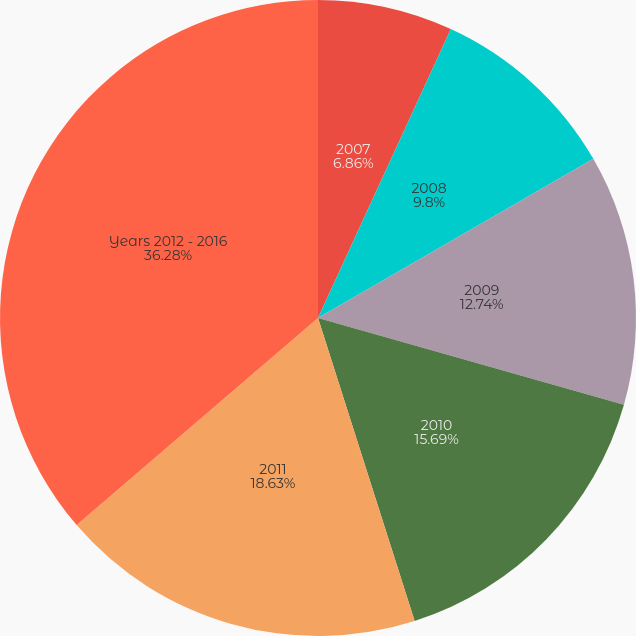Convert chart. <chart><loc_0><loc_0><loc_500><loc_500><pie_chart><fcel>2007<fcel>2008<fcel>2009<fcel>2010<fcel>2011<fcel>Years 2012 - 2016<nl><fcel>6.86%<fcel>9.8%<fcel>12.74%<fcel>15.69%<fcel>18.63%<fcel>36.29%<nl></chart> 